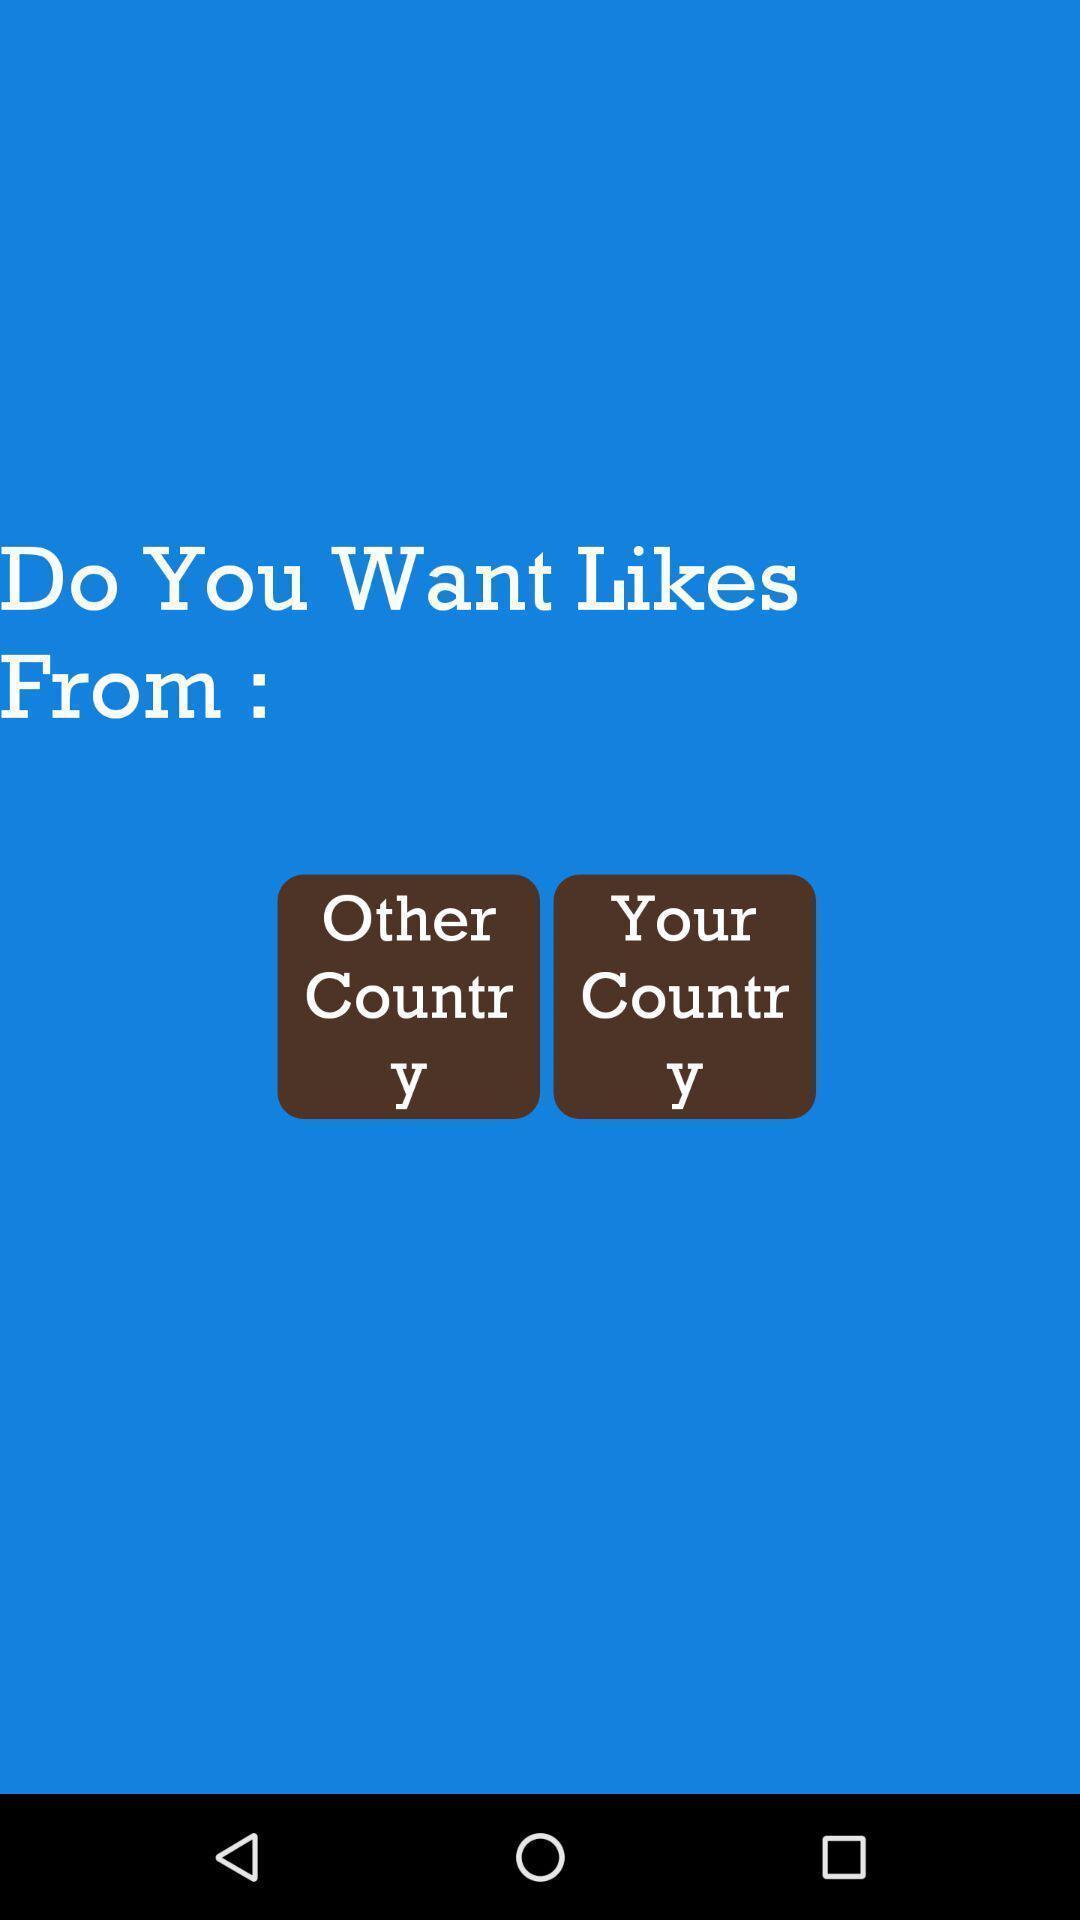What details can you identify in this image? Screen shows to get likes. 